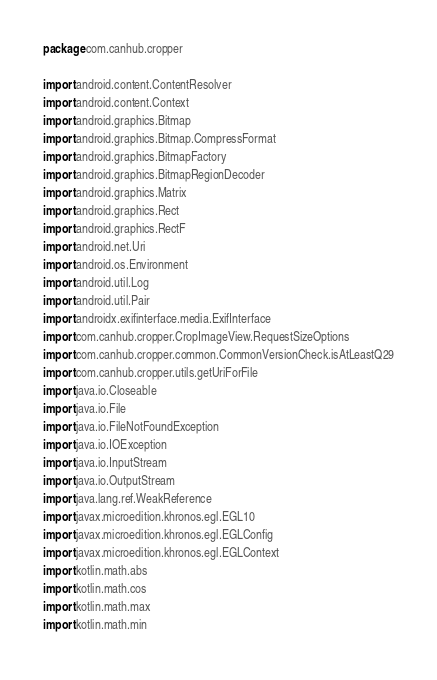Convert code to text. <code><loc_0><loc_0><loc_500><loc_500><_Kotlin_>package com.canhub.cropper

import android.content.ContentResolver
import android.content.Context
import android.graphics.Bitmap
import android.graphics.Bitmap.CompressFormat
import android.graphics.BitmapFactory
import android.graphics.BitmapRegionDecoder
import android.graphics.Matrix
import android.graphics.Rect
import android.graphics.RectF
import android.net.Uri
import android.os.Environment
import android.util.Log
import android.util.Pair
import androidx.exifinterface.media.ExifInterface
import com.canhub.cropper.CropImageView.RequestSizeOptions
import com.canhub.cropper.common.CommonVersionCheck.isAtLeastQ29
import com.canhub.cropper.utils.getUriForFile
import java.io.Closeable
import java.io.File
import java.io.FileNotFoundException
import java.io.IOException
import java.io.InputStream
import java.io.OutputStream
import java.lang.ref.WeakReference
import javax.microedition.khronos.egl.EGL10
import javax.microedition.khronos.egl.EGLConfig
import javax.microedition.khronos.egl.EGLContext
import kotlin.math.abs
import kotlin.math.cos
import kotlin.math.max
import kotlin.math.min</code> 